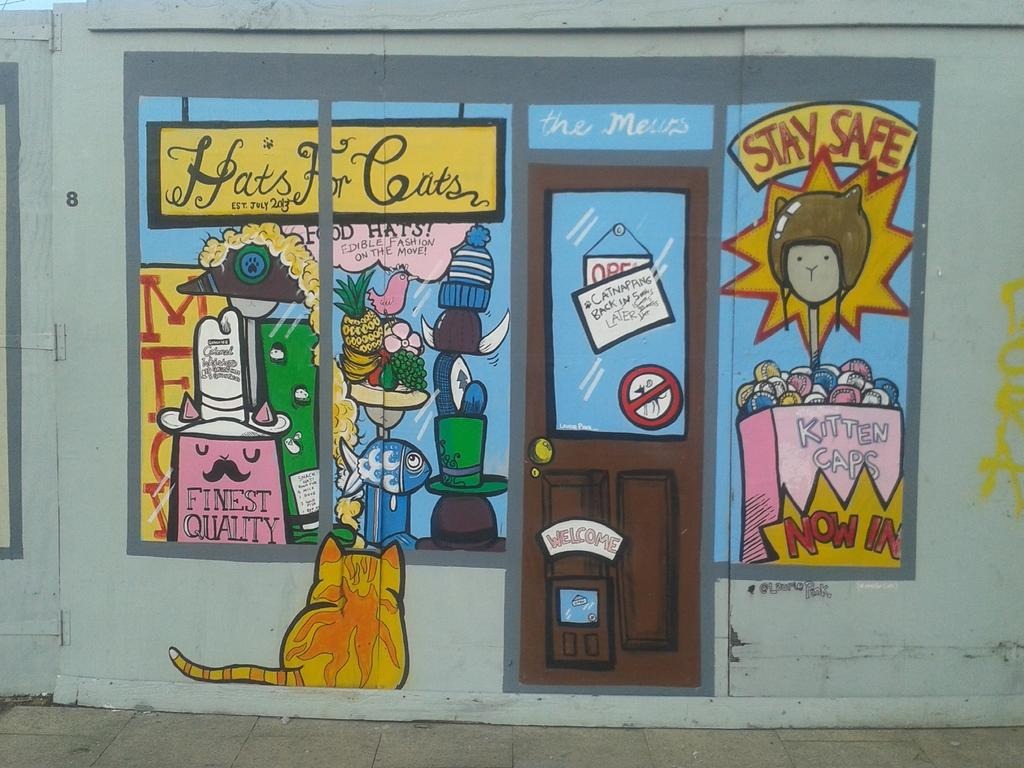What is present on the wall in the image? There is a painting of a door and a painting of a cat on the wall. What else can be seen on the wall besides the paintings? There are other things depicted in the painting on the wall, and there is text on the wall. Can you describe the paintings on the wall? There is a painting of a door and a painting of a cat on the wall. What type of pets are being discussed in the image? There is no discussion of pets in the image; it features paintings on a wall. Can you provide a copy of the receipt for the painting on the wall? There is no receipt present in the image; it only shows a wall with paintings and text. 